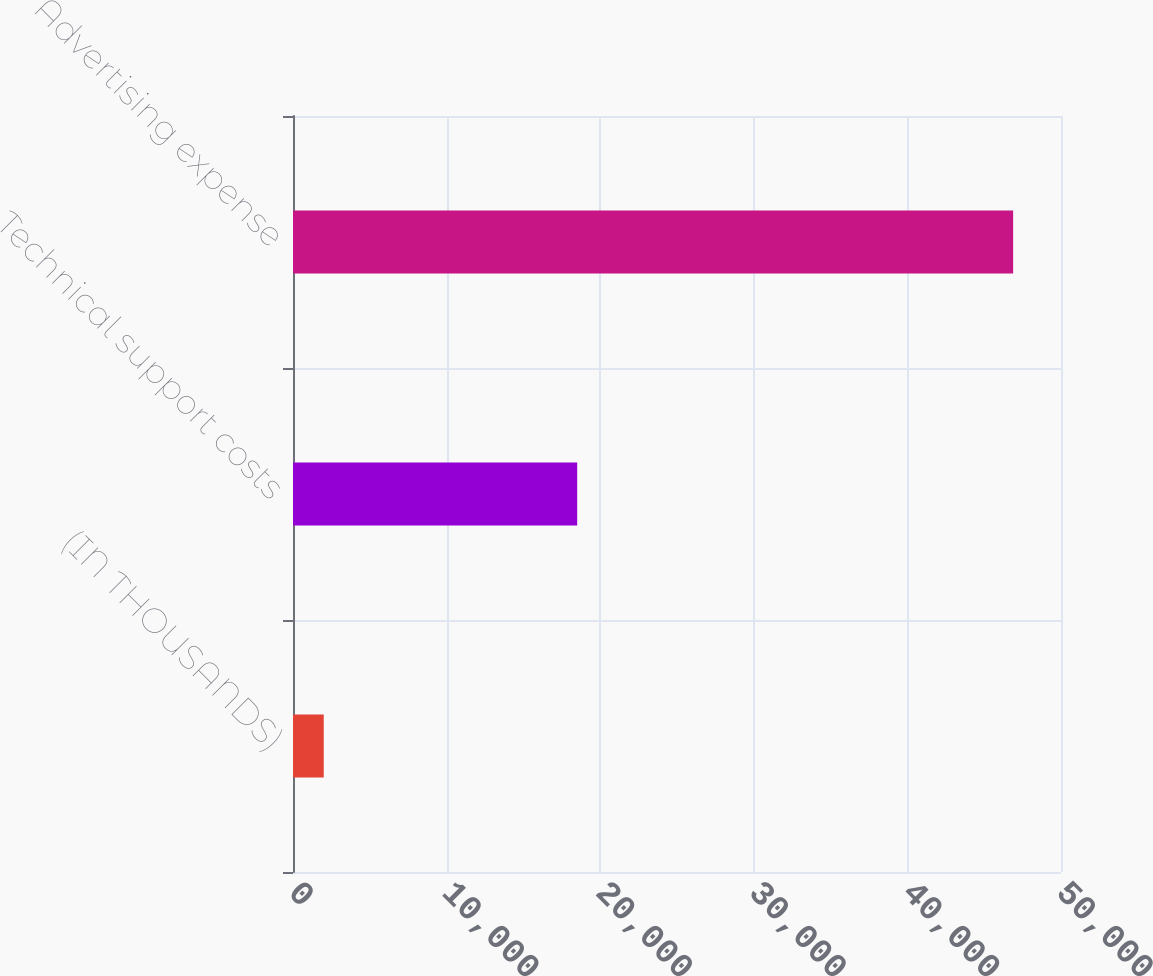<chart> <loc_0><loc_0><loc_500><loc_500><bar_chart><fcel>(IN THOUSANDS)<fcel>Technical support costs<fcel>Advertising expense<nl><fcel>2001<fcel>18502<fcel>46884<nl></chart> 